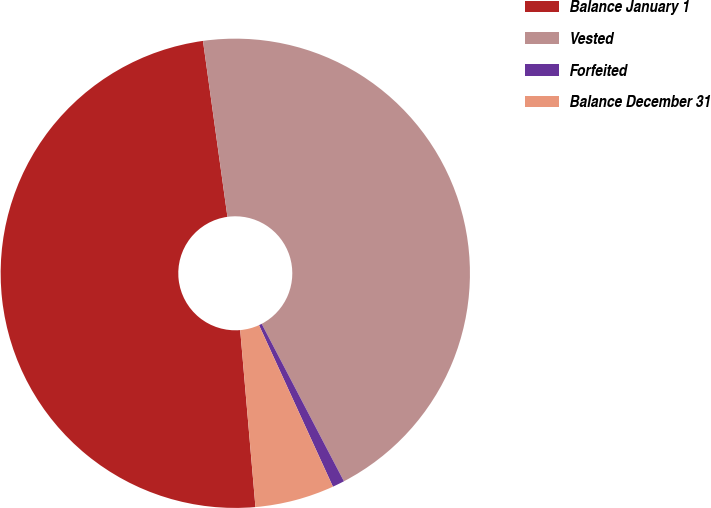Convert chart to OTSL. <chart><loc_0><loc_0><loc_500><loc_500><pie_chart><fcel>Balance January 1<fcel>Vested<fcel>Forfeited<fcel>Balance December 31<nl><fcel>49.17%<fcel>44.54%<fcel>0.83%<fcel>5.46%<nl></chart> 